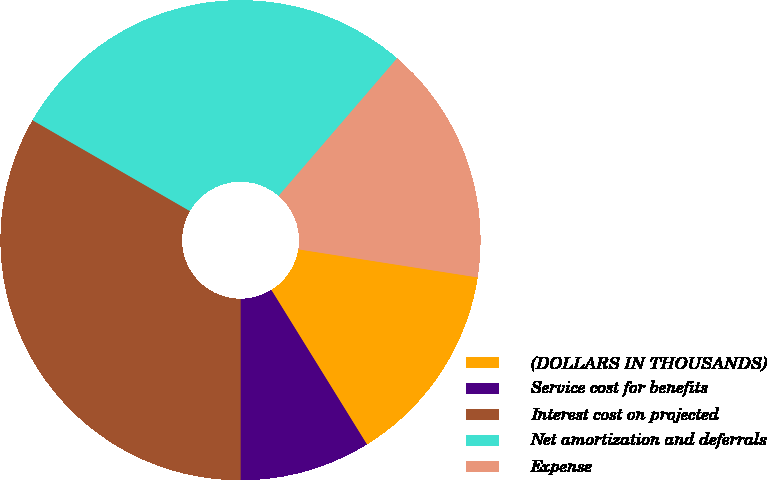Convert chart. <chart><loc_0><loc_0><loc_500><loc_500><pie_chart><fcel>(DOLLARS IN THOUSANDS)<fcel>Service cost for benefits<fcel>Interest cost on projected<fcel>Net amortization and deferrals<fcel>Expense<nl><fcel>13.71%<fcel>8.82%<fcel>33.33%<fcel>27.98%<fcel>16.16%<nl></chart> 